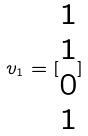<formula> <loc_0><loc_0><loc_500><loc_500>v _ { 1 } = [ \begin{matrix} 1 \\ 1 \\ 0 \\ 1 \end{matrix} ]</formula> 